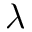Convert formula to latex. <formula><loc_0><loc_0><loc_500><loc_500>\lambda</formula> 